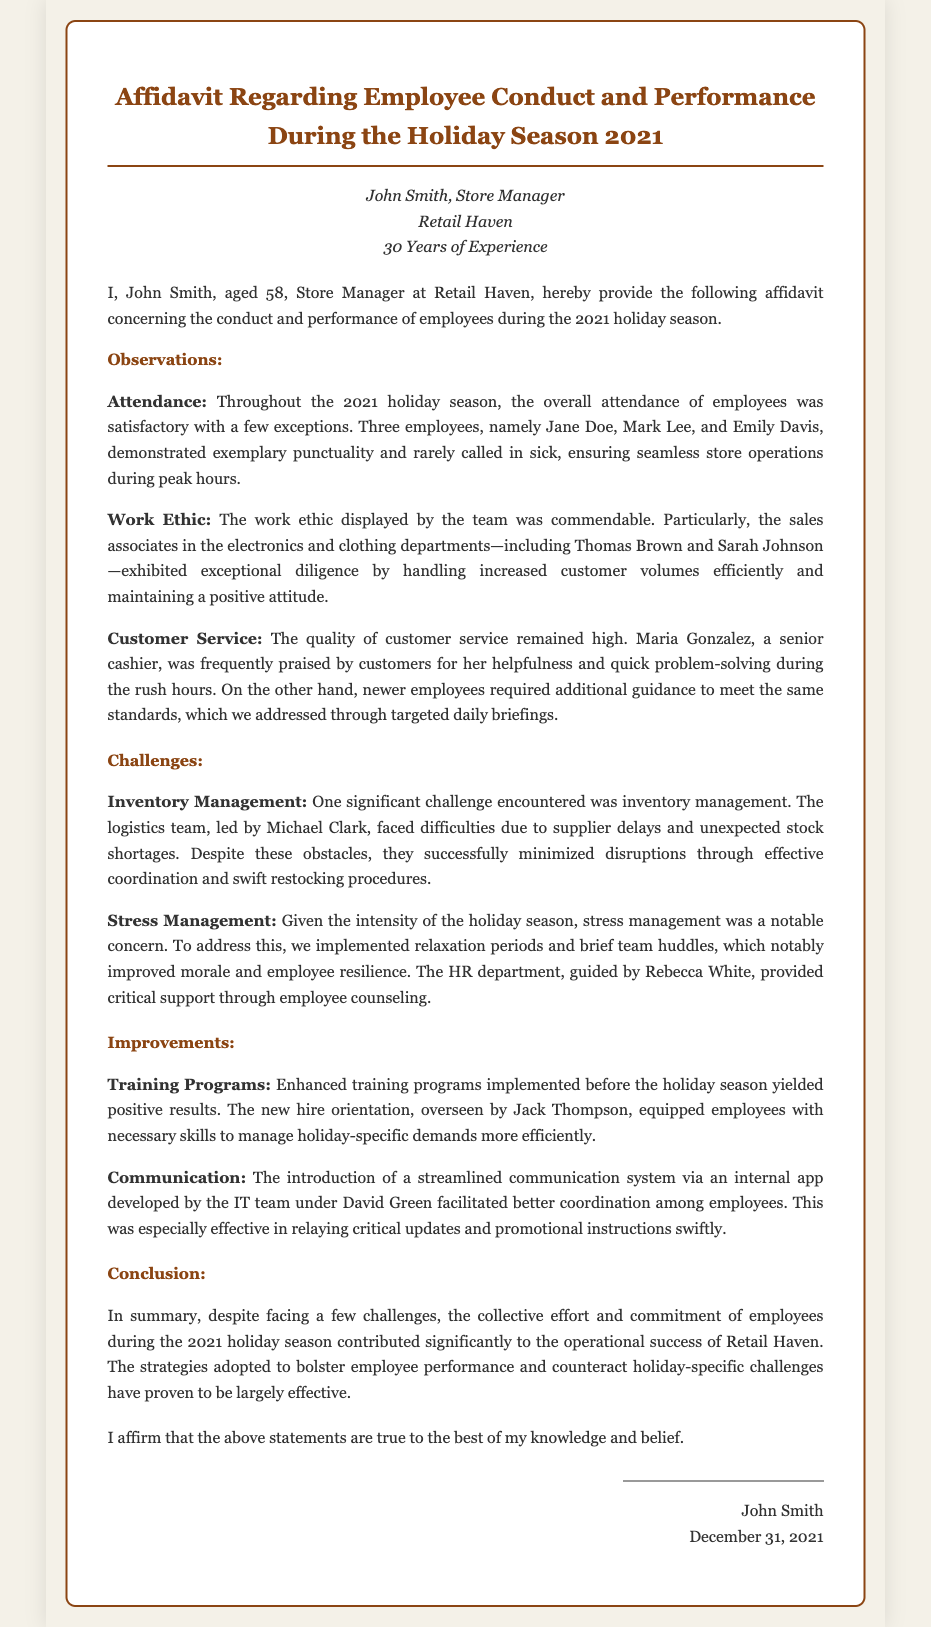What is the name of the store manager? The name of the store manager is mentioned at the beginning of the affidavit.
Answer: John Smith How many years of experience does the store manager have? The affidavit states the store manager's experience in years.
Answer: 30 Years Who provided critical support through employee counseling? The affidavit specifies that one individual from the HR department provided this support.
Answer: Rebecca White Which employee was praised for helpfulness during rush hours? The document specifically mentions a cashier recognized for her service.
Answer: Maria Gonzalez What was a significant challenge related to inventory? The affidavit notes a specific issue faced by the logistics team.
Answer: Supplier delays What solution was implemented to manage employee stress? The affidavit mentions a specific method used to alleviate stress among employees.
Answer: Relaxation periods What type of training programs were enhanced before the holiday season? The affidavit highlights the purpose of the training implemented.
Answer: New hire orientation What communication system was introduced during the holiday season? The document indicates the means used for improved communication.
Answer: Internal app What was the overall attendance of employees described as? The affidavit provides an evaluation of attendance during the holiday season.
Answer: Satisfactory 